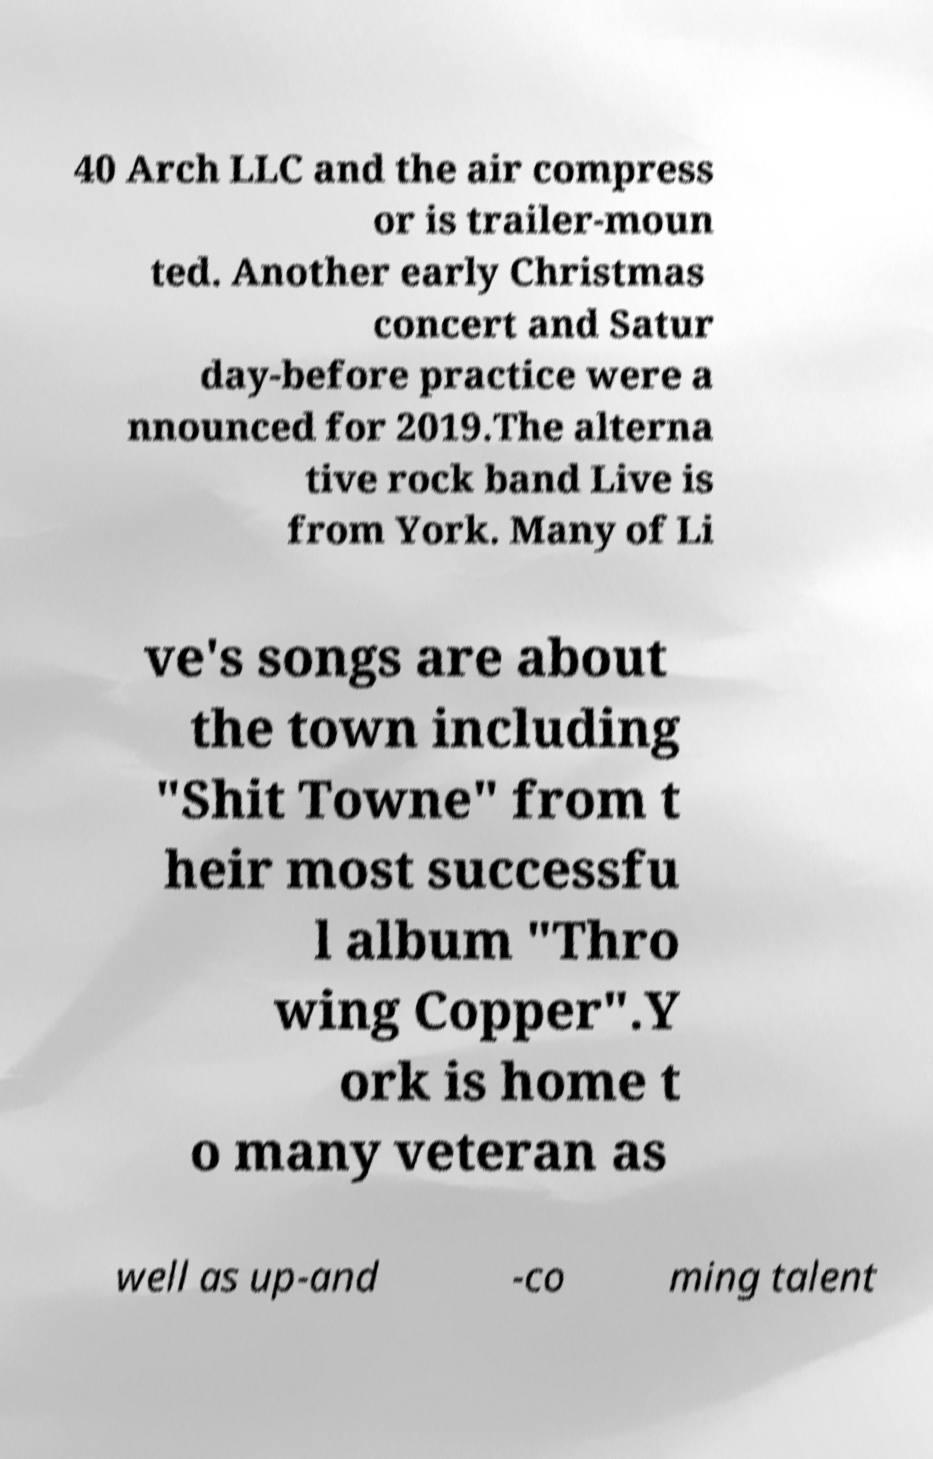There's text embedded in this image that I need extracted. Can you transcribe it verbatim? 40 Arch LLC and the air compress or is trailer-moun ted. Another early Christmas concert and Satur day-before practice were a nnounced for 2019.The alterna tive rock band Live is from York. Many of Li ve's songs are about the town including "Shit Towne" from t heir most successfu l album "Thro wing Copper".Y ork is home t o many veteran as well as up-and -co ming talent 